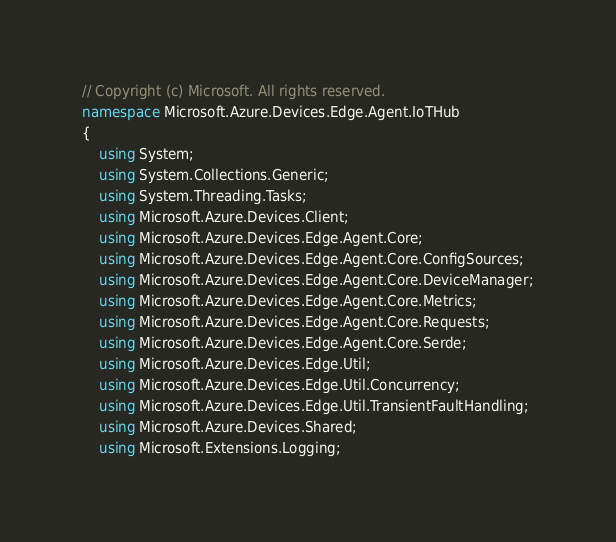<code> <loc_0><loc_0><loc_500><loc_500><_C#_>// Copyright (c) Microsoft. All rights reserved.
namespace Microsoft.Azure.Devices.Edge.Agent.IoTHub
{
    using System;
    using System.Collections.Generic;
    using System.Threading.Tasks;
    using Microsoft.Azure.Devices.Client;
    using Microsoft.Azure.Devices.Edge.Agent.Core;
    using Microsoft.Azure.Devices.Edge.Agent.Core.ConfigSources;
    using Microsoft.Azure.Devices.Edge.Agent.Core.DeviceManager;
    using Microsoft.Azure.Devices.Edge.Agent.Core.Metrics;
    using Microsoft.Azure.Devices.Edge.Agent.Core.Requests;
    using Microsoft.Azure.Devices.Edge.Agent.Core.Serde;
    using Microsoft.Azure.Devices.Edge.Util;
    using Microsoft.Azure.Devices.Edge.Util.Concurrency;
    using Microsoft.Azure.Devices.Edge.Util.TransientFaultHandling;
    using Microsoft.Azure.Devices.Shared;
    using Microsoft.Extensions.Logging;</code> 